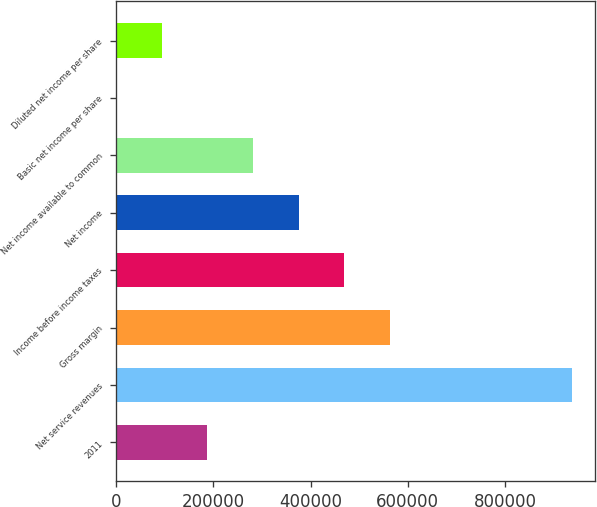Convert chart. <chart><loc_0><loc_0><loc_500><loc_500><bar_chart><fcel>2011<fcel>Net service revenues<fcel>Gross margin<fcel>Income before income taxes<fcel>Net income<fcel>Net income available to common<fcel>Basic net income per share<fcel>Diluted net income per share<nl><fcel>187593<fcel>937966<fcel>562780<fcel>468983<fcel>375187<fcel>281390<fcel>0.25<fcel>93796.8<nl></chart> 